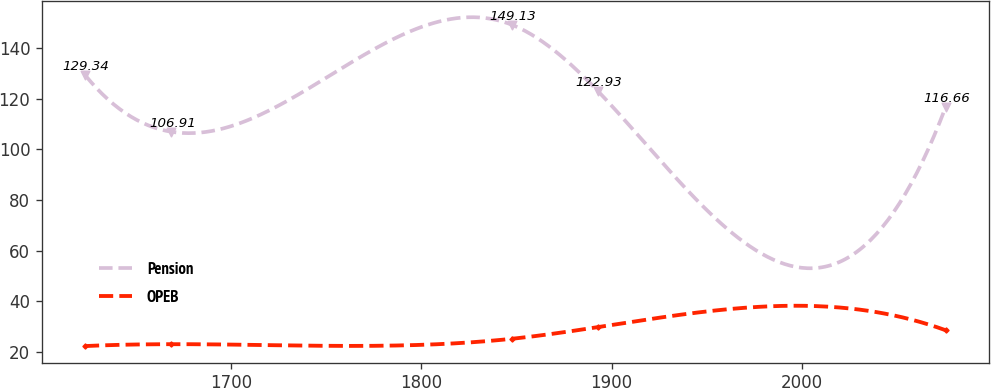Convert chart. <chart><loc_0><loc_0><loc_500><loc_500><line_chart><ecel><fcel>Pension<fcel>OPEB<nl><fcel>1623.09<fcel>129.34<fcel>22.29<nl><fcel>1668.34<fcel>106.91<fcel>23.04<nl><fcel>1847.54<fcel>149.13<fcel>25.17<nl><fcel>1892.79<fcel>122.93<fcel>29.78<nl><fcel>2075.58<fcel>116.66<fcel>28.54<nl></chart> 